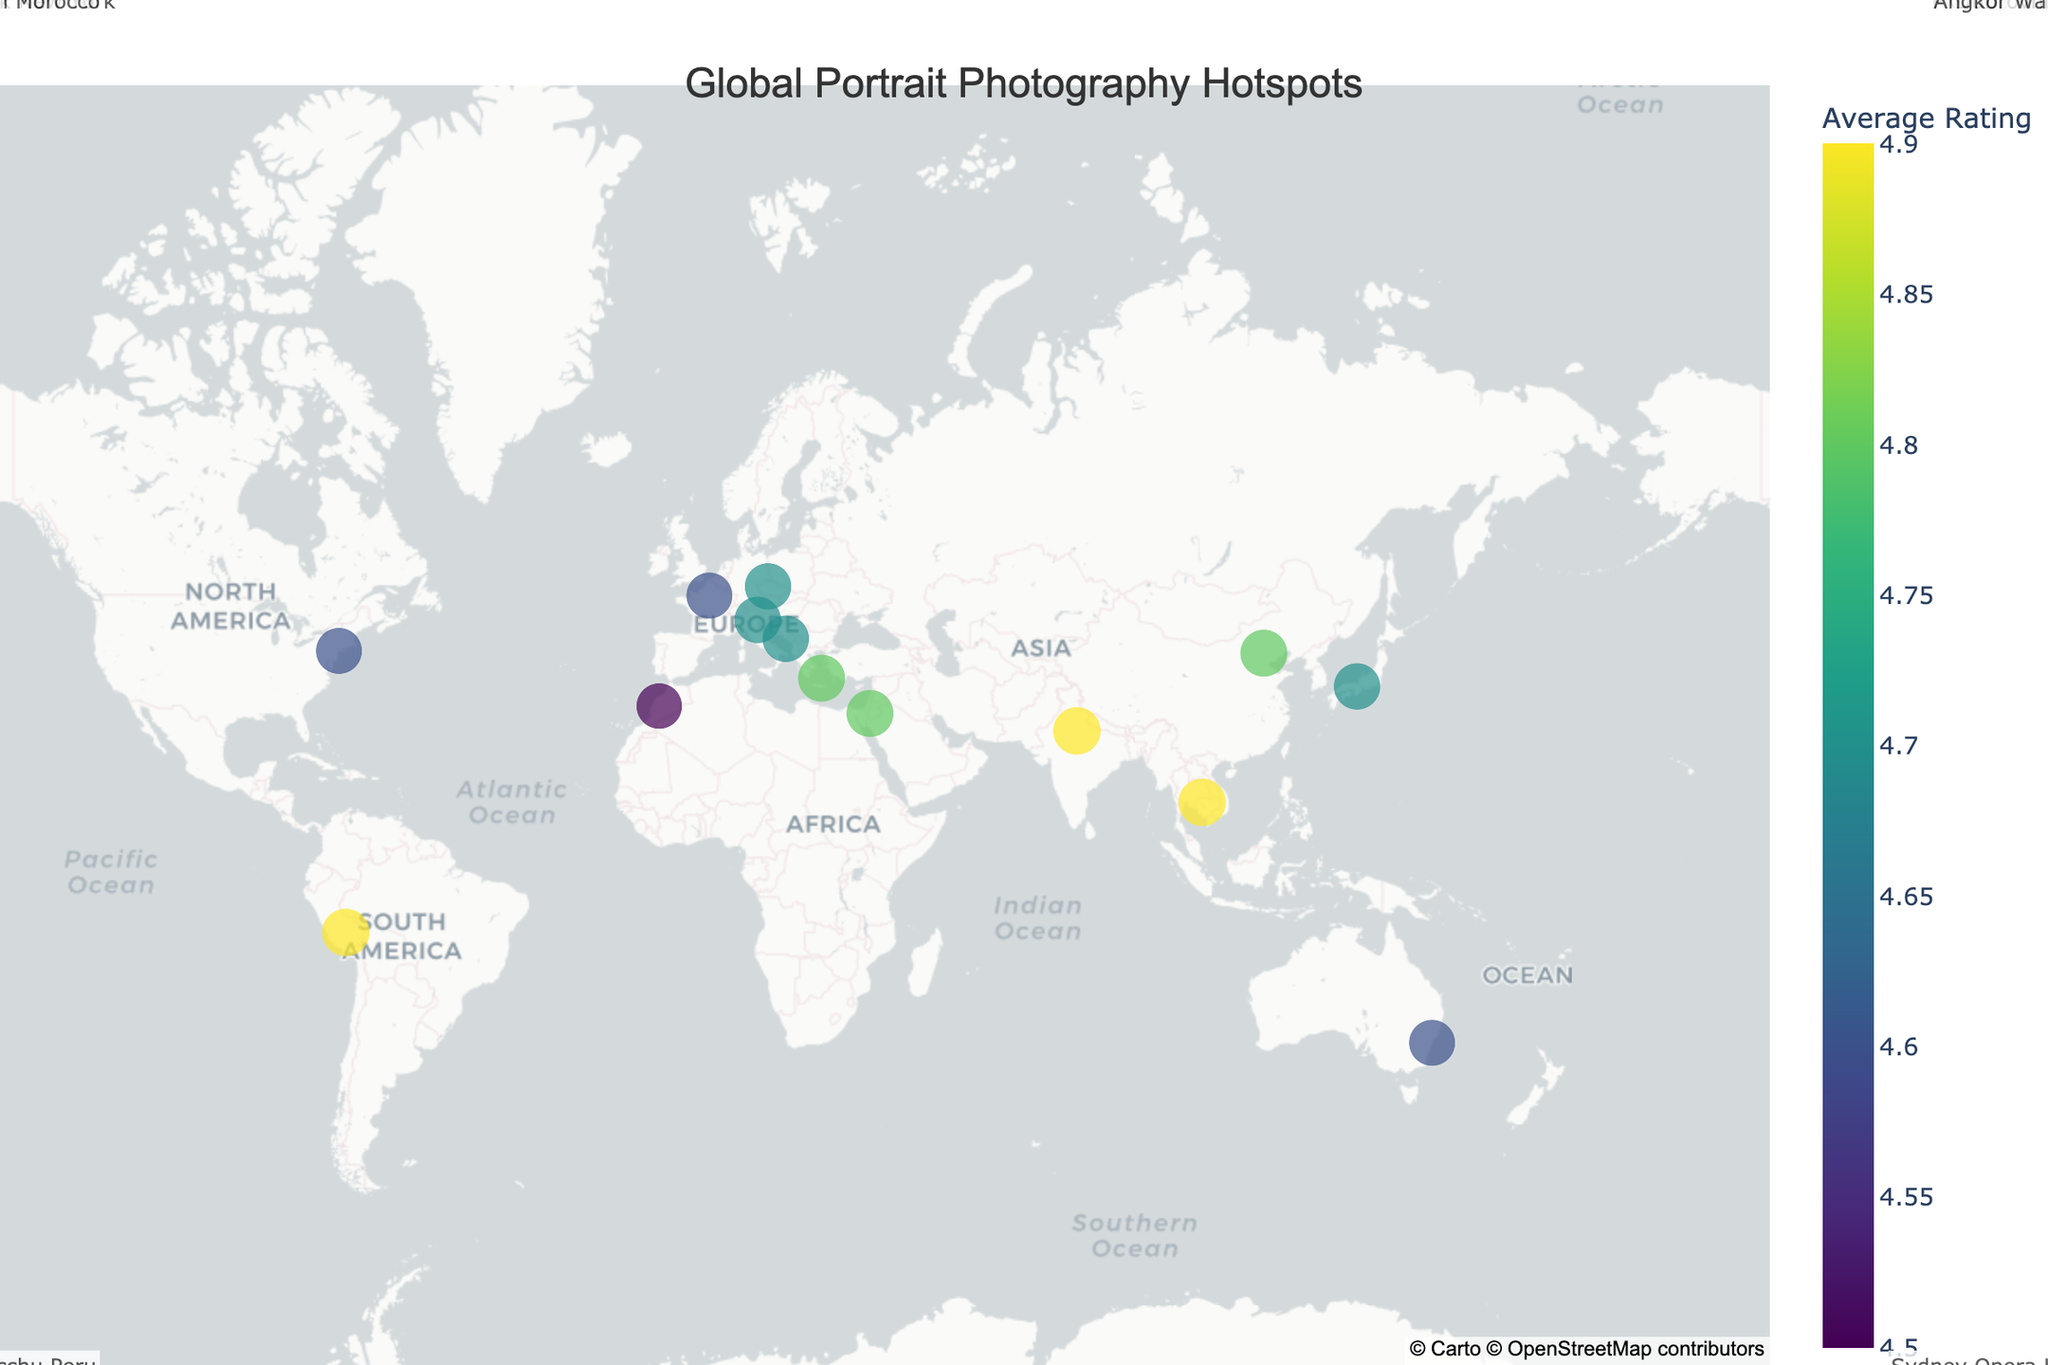What is the average rating of the most popular portrait photography location on the plot? Identify the highest rating on the map. The highest value in the dataset is 4.9.
Answer: 4.9 Which location has the highest visitor rating? Look for the location with the highest average rating. Both Taj Mahal and Machu Picchu have the highest rating of 4.9.
Answer: Taj Mahal or Machu Picchu Which location is the least popular based on visitor ratings in the plot? Identify the location with the lowest average rating. Marrakech has the lowest rating at 4.5.
Answer: Marrakech How many locations have an average rating of 4.8 or higher? Count the locations with an average rating of at least 4.8. There are 6 such locations.
Answer: 6 What is the average rating across all locations shown on the plot? Sum all the ratings and divide by the number of locations. (4.8 + 4.6 + 4.9 + 4.7 + 4.5 + 4.7 + 4.8 + 4.6 + 4.9 + 4.7 + 4.6 + 4.8 + 4.7 + 4.9)/14 = 4.742857 ≈ 4.74
Answer: 4.74 Which continents have more than one popular portrait photography location? Identify the continents from the map. Asia has 4 locations, Europe has 3, North America has 1, South America has 1, Australia has 1, and Africa has 1. So, Asia and Europe have more than one location.
Answer: Asia, Europe What is the rating difference between Santorini, Greece, and Central Park, New York? Subtract the lower rating from the higher one. 4.8 - 4.6 = 0.2
Answer: 0.2 Which location in Asia has the highest average rating? Identify the locations in Asia and compare their ratings. Taj Mahal and Angkor Wat both have a rating of 4.9.
Answer: Taj Mahal or Angkor Wat Which location in Europe has the highest average rating? Identify the locations in Europe and compare their ratings. Prague has the highest rating at 4.7.
Answer: Prague How are the popular photography locations distributed across the globe? Observe the placement of the markers on the map. They are spread across all continents with higher concentrations in Europe and Asia.
Answer: Spread across continents, dense in Europe and Asia 